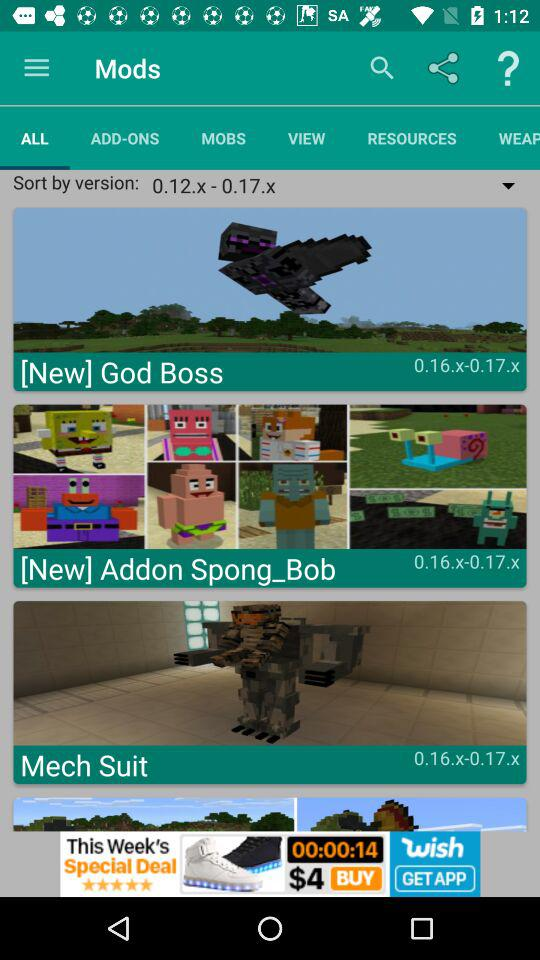How many items have a version number between 0.16.x and 0.17.x?
Answer the question using a single word or phrase. 3 